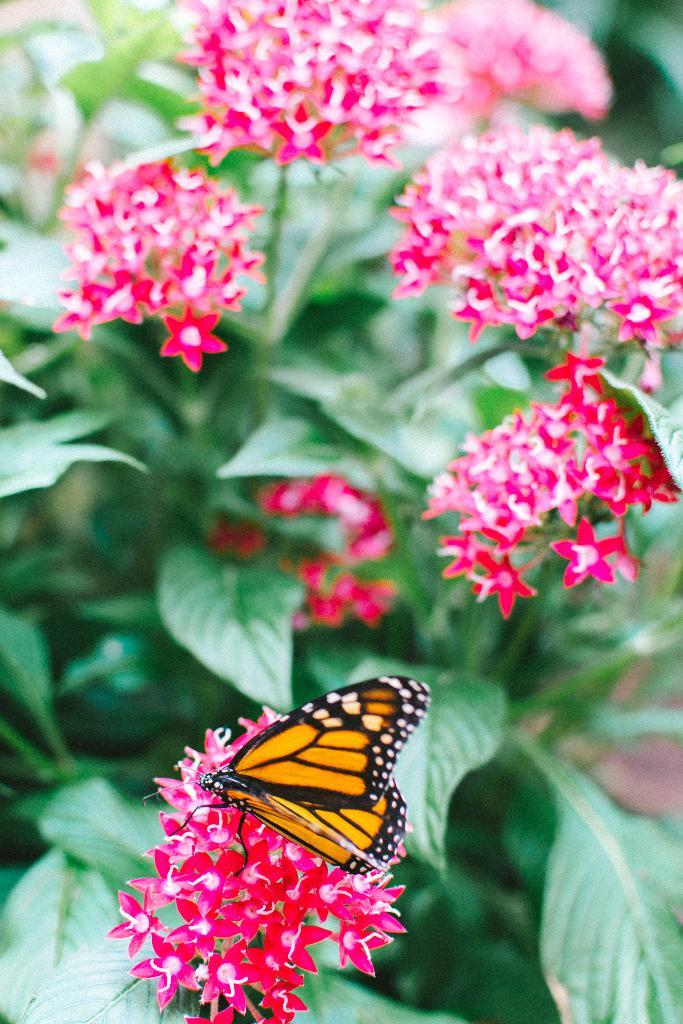What type of animal can be seen in the image? There is a butterfly in the image. What can be seen in the background of the image? There are flowers on plants in the background of the image. What type of glove is the butterfly wearing in the image? There is no glove present in the image, as butterflies do not wear gloves. 